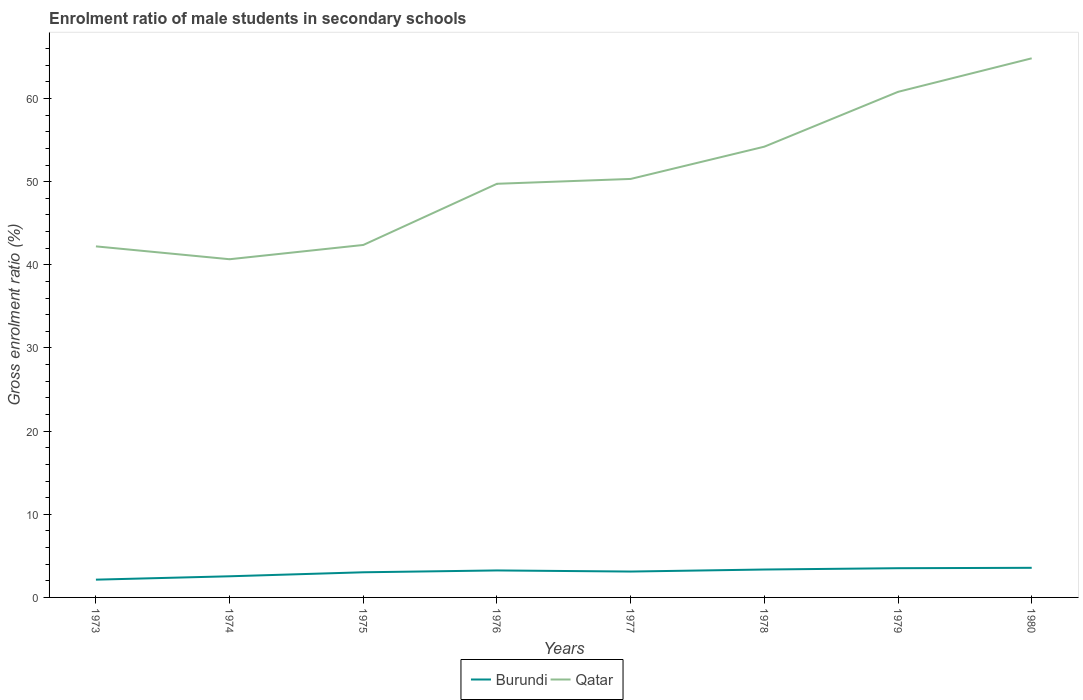How many different coloured lines are there?
Keep it short and to the point. 2. Does the line corresponding to Burundi intersect with the line corresponding to Qatar?
Offer a terse response. No. Across all years, what is the maximum enrolment ratio of male students in secondary schools in Qatar?
Offer a very short reply. 40.68. What is the total enrolment ratio of male students in secondary schools in Burundi in the graph?
Ensure brevity in your answer.  -0.57. What is the difference between the highest and the second highest enrolment ratio of male students in secondary schools in Qatar?
Give a very brief answer. 24.16. What is the difference between the highest and the lowest enrolment ratio of male students in secondary schools in Qatar?
Your answer should be very brief. 3. Is the enrolment ratio of male students in secondary schools in Qatar strictly greater than the enrolment ratio of male students in secondary schools in Burundi over the years?
Your response must be concise. No. How many years are there in the graph?
Provide a succinct answer. 8. What is the difference between two consecutive major ticks on the Y-axis?
Your answer should be very brief. 10. Does the graph contain any zero values?
Your response must be concise. No. Does the graph contain grids?
Ensure brevity in your answer.  No. How are the legend labels stacked?
Ensure brevity in your answer.  Horizontal. What is the title of the graph?
Your response must be concise. Enrolment ratio of male students in secondary schools. Does "Dominica" appear as one of the legend labels in the graph?
Your answer should be compact. No. What is the label or title of the X-axis?
Your answer should be compact. Years. What is the label or title of the Y-axis?
Offer a terse response. Gross enrolment ratio (%). What is the Gross enrolment ratio (%) of Burundi in 1973?
Provide a short and direct response. 2.14. What is the Gross enrolment ratio (%) of Qatar in 1973?
Offer a terse response. 42.22. What is the Gross enrolment ratio (%) of Burundi in 1974?
Offer a very short reply. 2.54. What is the Gross enrolment ratio (%) in Qatar in 1974?
Your answer should be very brief. 40.68. What is the Gross enrolment ratio (%) of Burundi in 1975?
Ensure brevity in your answer.  3.02. What is the Gross enrolment ratio (%) in Qatar in 1975?
Provide a short and direct response. 42.39. What is the Gross enrolment ratio (%) of Burundi in 1976?
Give a very brief answer. 3.25. What is the Gross enrolment ratio (%) of Qatar in 1976?
Ensure brevity in your answer.  49.75. What is the Gross enrolment ratio (%) in Burundi in 1977?
Your answer should be compact. 3.11. What is the Gross enrolment ratio (%) of Qatar in 1977?
Provide a succinct answer. 50.33. What is the Gross enrolment ratio (%) of Burundi in 1978?
Your answer should be very brief. 3.36. What is the Gross enrolment ratio (%) of Qatar in 1978?
Offer a very short reply. 54.21. What is the Gross enrolment ratio (%) of Burundi in 1979?
Keep it short and to the point. 3.52. What is the Gross enrolment ratio (%) in Qatar in 1979?
Your answer should be compact. 60.81. What is the Gross enrolment ratio (%) in Burundi in 1980?
Your response must be concise. 3.56. What is the Gross enrolment ratio (%) in Qatar in 1980?
Your answer should be compact. 64.84. Across all years, what is the maximum Gross enrolment ratio (%) of Burundi?
Provide a succinct answer. 3.56. Across all years, what is the maximum Gross enrolment ratio (%) of Qatar?
Ensure brevity in your answer.  64.84. Across all years, what is the minimum Gross enrolment ratio (%) of Burundi?
Ensure brevity in your answer.  2.14. Across all years, what is the minimum Gross enrolment ratio (%) in Qatar?
Your answer should be compact. 40.68. What is the total Gross enrolment ratio (%) of Burundi in the graph?
Your answer should be very brief. 24.5. What is the total Gross enrolment ratio (%) of Qatar in the graph?
Offer a very short reply. 405.24. What is the difference between the Gross enrolment ratio (%) of Burundi in 1973 and that in 1974?
Ensure brevity in your answer.  -0.41. What is the difference between the Gross enrolment ratio (%) in Qatar in 1973 and that in 1974?
Your answer should be very brief. 1.55. What is the difference between the Gross enrolment ratio (%) of Burundi in 1973 and that in 1975?
Give a very brief answer. -0.89. What is the difference between the Gross enrolment ratio (%) in Qatar in 1973 and that in 1975?
Your response must be concise. -0.17. What is the difference between the Gross enrolment ratio (%) in Burundi in 1973 and that in 1976?
Your answer should be compact. -1.11. What is the difference between the Gross enrolment ratio (%) of Qatar in 1973 and that in 1976?
Offer a very short reply. -7.53. What is the difference between the Gross enrolment ratio (%) of Burundi in 1973 and that in 1977?
Your answer should be compact. -0.97. What is the difference between the Gross enrolment ratio (%) of Qatar in 1973 and that in 1977?
Offer a very short reply. -8.11. What is the difference between the Gross enrolment ratio (%) of Burundi in 1973 and that in 1978?
Offer a very short reply. -1.22. What is the difference between the Gross enrolment ratio (%) of Qatar in 1973 and that in 1978?
Ensure brevity in your answer.  -11.99. What is the difference between the Gross enrolment ratio (%) in Burundi in 1973 and that in 1979?
Your answer should be compact. -1.38. What is the difference between the Gross enrolment ratio (%) of Qatar in 1973 and that in 1979?
Offer a very short reply. -18.58. What is the difference between the Gross enrolment ratio (%) of Burundi in 1973 and that in 1980?
Offer a terse response. -1.42. What is the difference between the Gross enrolment ratio (%) in Qatar in 1973 and that in 1980?
Keep it short and to the point. -22.62. What is the difference between the Gross enrolment ratio (%) in Burundi in 1974 and that in 1975?
Your response must be concise. -0.48. What is the difference between the Gross enrolment ratio (%) in Qatar in 1974 and that in 1975?
Give a very brief answer. -1.72. What is the difference between the Gross enrolment ratio (%) of Burundi in 1974 and that in 1976?
Provide a short and direct response. -0.7. What is the difference between the Gross enrolment ratio (%) of Qatar in 1974 and that in 1976?
Provide a succinct answer. -9.07. What is the difference between the Gross enrolment ratio (%) of Burundi in 1974 and that in 1977?
Your answer should be compact. -0.57. What is the difference between the Gross enrolment ratio (%) in Qatar in 1974 and that in 1977?
Your answer should be very brief. -9.66. What is the difference between the Gross enrolment ratio (%) of Burundi in 1974 and that in 1978?
Ensure brevity in your answer.  -0.81. What is the difference between the Gross enrolment ratio (%) of Qatar in 1974 and that in 1978?
Make the answer very short. -13.54. What is the difference between the Gross enrolment ratio (%) of Burundi in 1974 and that in 1979?
Your answer should be very brief. -0.97. What is the difference between the Gross enrolment ratio (%) of Qatar in 1974 and that in 1979?
Offer a terse response. -20.13. What is the difference between the Gross enrolment ratio (%) of Burundi in 1974 and that in 1980?
Offer a terse response. -1.02. What is the difference between the Gross enrolment ratio (%) in Qatar in 1974 and that in 1980?
Ensure brevity in your answer.  -24.16. What is the difference between the Gross enrolment ratio (%) of Burundi in 1975 and that in 1976?
Provide a succinct answer. -0.22. What is the difference between the Gross enrolment ratio (%) in Qatar in 1975 and that in 1976?
Ensure brevity in your answer.  -7.36. What is the difference between the Gross enrolment ratio (%) of Burundi in 1975 and that in 1977?
Give a very brief answer. -0.09. What is the difference between the Gross enrolment ratio (%) in Qatar in 1975 and that in 1977?
Ensure brevity in your answer.  -7.94. What is the difference between the Gross enrolment ratio (%) in Burundi in 1975 and that in 1978?
Make the answer very short. -0.33. What is the difference between the Gross enrolment ratio (%) of Qatar in 1975 and that in 1978?
Offer a very short reply. -11.82. What is the difference between the Gross enrolment ratio (%) in Burundi in 1975 and that in 1979?
Your answer should be very brief. -0.49. What is the difference between the Gross enrolment ratio (%) in Qatar in 1975 and that in 1979?
Provide a short and direct response. -18.42. What is the difference between the Gross enrolment ratio (%) of Burundi in 1975 and that in 1980?
Your response must be concise. -0.54. What is the difference between the Gross enrolment ratio (%) of Qatar in 1975 and that in 1980?
Ensure brevity in your answer.  -22.45. What is the difference between the Gross enrolment ratio (%) in Burundi in 1976 and that in 1977?
Provide a succinct answer. 0.13. What is the difference between the Gross enrolment ratio (%) in Qatar in 1976 and that in 1977?
Give a very brief answer. -0.58. What is the difference between the Gross enrolment ratio (%) of Burundi in 1976 and that in 1978?
Your response must be concise. -0.11. What is the difference between the Gross enrolment ratio (%) in Qatar in 1976 and that in 1978?
Provide a short and direct response. -4.46. What is the difference between the Gross enrolment ratio (%) in Burundi in 1976 and that in 1979?
Provide a succinct answer. -0.27. What is the difference between the Gross enrolment ratio (%) of Qatar in 1976 and that in 1979?
Your answer should be very brief. -11.06. What is the difference between the Gross enrolment ratio (%) in Burundi in 1976 and that in 1980?
Offer a very short reply. -0.32. What is the difference between the Gross enrolment ratio (%) of Qatar in 1976 and that in 1980?
Keep it short and to the point. -15.09. What is the difference between the Gross enrolment ratio (%) of Burundi in 1977 and that in 1978?
Offer a terse response. -0.25. What is the difference between the Gross enrolment ratio (%) in Qatar in 1977 and that in 1978?
Your answer should be compact. -3.88. What is the difference between the Gross enrolment ratio (%) in Burundi in 1977 and that in 1979?
Offer a terse response. -0.4. What is the difference between the Gross enrolment ratio (%) in Qatar in 1977 and that in 1979?
Keep it short and to the point. -10.47. What is the difference between the Gross enrolment ratio (%) of Burundi in 1977 and that in 1980?
Offer a very short reply. -0.45. What is the difference between the Gross enrolment ratio (%) in Qatar in 1977 and that in 1980?
Provide a short and direct response. -14.51. What is the difference between the Gross enrolment ratio (%) of Burundi in 1978 and that in 1979?
Your answer should be very brief. -0.16. What is the difference between the Gross enrolment ratio (%) of Qatar in 1978 and that in 1979?
Your response must be concise. -6.59. What is the difference between the Gross enrolment ratio (%) of Burundi in 1978 and that in 1980?
Provide a short and direct response. -0.2. What is the difference between the Gross enrolment ratio (%) in Qatar in 1978 and that in 1980?
Keep it short and to the point. -10.63. What is the difference between the Gross enrolment ratio (%) of Burundi in 1979 and that in 1980?
Provide a succinct answer. -0.05. What is the difference between the Gross enrolment ratio (%) of Qatar in 1979 and that in 1980?
Your response must be concise. -4.03. What is the difference between the Gross enrolment ratio (%) in Burundi in 1973 and the Gross enrolment ratio (%) in Qatar in 1974?
Provide a succinct answer. -38.54. What is the difference between the Gross enrolment ratio (%) of Burundi in 1973 and the Gross enrolment ratio (%) of Qatar in 1975?
Offer a terse response. -40.25. What is the difference between the Gross enrolment ratio (%) in Burundi in 1973 and the Gross enrolment ratio (%) in Qatar in 1976?
Provide a succinct answer. -47.61. What is the difference between the Gross enrolment ratio (%) of Burundi in 1973 and the Gross enrolment ratio (%) of Qatar in 1977?
Your response must be concise. -48.2. What is the difference between the Gross enrolment ratio (%) of Burundi in 1973 and the Gross enrolment ratio (%) of Qatar in 1978?
Provide a succinct answer. -52.08. What is the difference between the Gross enrolment ratio (%) of Burundi in 1973 and the Gross enrolment ratio (%) of Qatar in 1979?
Offer a very short reply. -58.67. What is the difference between the Gross enrolment ratio (%) in Burundi in 1973 and the Gross enrolment ratio (%) in Qatar in 1980?
Your response must be concise. -62.7. What is the difference between the Gross enrolment ratio (%) of Burundi in 1974 and the Gross enrolment ratio (%) of Qatar in 1975?
Provide a short and direct response. -39.85. What is the difference between the Gross enrolment ratio (%) in Burundi in 1974 and the Gross enrolment ratio (%) in Qatar in 1976?
Your answer should be compact. -47.21. What is the difference between the Gross enrolment ratio (%) of Burundi in 1974 and the Gross enrolment ratio (%) of Qatar in 1977?
Keep it short and to the point. -47.79. What is the difference between the Gross enrolment ratio (%) in Burundi in 1974 and the Gross enrolment ratio (%) in Qatar in 1978?
Offer a very short reply. -51.67. What is the difference between the Gross enrolment ratio (%) in Burundi in 1974 and the Gross enrolment ratio (%) in Qatar in 1979?
Make the answer very short. -58.26. What is the difference between the Gross enrolment ratio (%) of Burundi in 1974 and the Gross enrolment ratio (%) of Qatar in 1980?
Keep it short and to the point. -62.3. What is the difference between the Gross enrolment ratio (%) of Burundi in 1975 and the Gross enrolment ratio (%) of Qatar in 1976?
Offer a terse response. -46.73. What is the difference between the Gross enrolment ratio (%) in Burundi in 1975 and the Gross enrolment ratio (%) in Qatar in 1977?
Provide a succinct answer. -47.31. What is the difference between the Gross enrolment ratio (%) in Burundi in 1975 and the Gross enrolment ratio (%) in Qatar in 1978?
Provide a succinct answer. -51.19. What is the difference between the Gross enrolment ratio (%) in Burundi in 1975 and the Gross enrolment ratio (%) in Qatar in 1979?
Make the answer very short. -57.78. What is the difference between the Gross enrolment ratio (%) in Burundi in 1975 and the Gross enrolment ratio (%) in Qatar in 1980?
Provide a short and direct response. -61.82. What is the difference between the Gross enrolment ratio (%) of Burundi in 1976 and the Gross enrolment ratio (%) of Qatar in 1977?
Your response must be concise. -47.09. What is the difference between the Gross enrolment ratio (%) in Burundi in 1976 and the Gross enrolment ratio (%) in Qatar in 1978?
Your response must be concise. -50.97. What is the difference between the Gross enrolment ratio (%) in Burundi in 1976 and the Gross enrolment ratio (%) in Qatar in 1979?
Your answer should be compact. -57.56. What is the difference between the Gross enrolment ratio (%) in Burundi in 1976 and the Gross enrolment ratio (%) in Qatar in 1980?
Keep it short and to the point. -61.6. What is the difference between the Gross enrolment ratio (%) in Burundi in 1977 and the Gross enrolment ratio (%) in Qatar in 1978?
Offer a very short reply. -51.1. What is the difference between the Gross enrolment ratio (%) in Burundi in 1977 and the Gross enrolment ratio (%) in Qatar in 1979?
Give a very brief answer. -57.7. What is the difference between the Gross enrolment ratio (%) in Burundi in 1977 and the Gross enrolment ratio (%) in Qatar in 1980?
Offer a very short reply. -61.73. What is the difference between the Gross enrolment ratio (%) of Burundi in 1978 and the Gross enrolment ratio (%) of Qatar in 1979?
Ensure brevity in your answer.  -57.45. What is the difference between the Gross enrolment ratio (%) of Burundi in 1978 and the Gross enrolment ratio (%) of Qatar in 1980?
Your response must be concise. -61.48. What is the difference between the Gross enrolment ratio (%) in Burundi in 1979 and the Gross enrolment ratio (%) in Qatar in 1980?
Give a very brief answer. -61.33. What is the average Gross enrolment ratio (%) in Burundi per year?
Provide a succinct answer. 3.06. What is the average Gross enrolment ratio (%) of Qatar per year?
Your answer should be very brief. 50.65. In the year 1973, what is the difference between the Gross enrolment ratio (%) of Burundi and Gross enrolment ratio (%) of Qatar?
Your response must be concise. -40.09. In the year 1974, what is the difference between the Gross enrolment ratio (%) in Burundi and Gross enrolment ratio (%) in Qatar?
Your response must be concise. -38.13. In the year 1975, what is the difference between the Gross enrolment ratio (%) of Burundi and Gross enrolment ratio (%) of Qatar?
Offer a terse response. -39.37. In the year 1976, what is the difference between the Gross enrolment ratio (%) in Burundi and Gross enrolment ratio (%) in Qatar?
Provide a succinct answer. -46.5. In the year 1977, what is the difference between the Gross enrolment ratio (%) in Burundi and Gross enrolment ratio (%) in Qatar?
Offer a very short reply. -47.22. In the year 1978, what is the difference between the Gross enrolment ratio (%) in Burundi and Gross enrolment ratio (%) in Qatar?
Your answer should be very brief. -50.86. In the year 1979, what is the difference between the Gross enrolment ratio (%) in Burundi and Gross enrolment ratio (%) in Qatar?
Provide a succinct answer. -57.29. In the year 1980, what is the difference between the Gross enrolment ratio (%) of Burundi and Gross enrolment ratio (%) of Qatar?
Your answer should be very brief. -61.28. What is the ratio of the Gross enrolment ratio (%) of Burundi in 1973 to that in 1974?
Ensure brevity in your answer.  0.84. What is the ratio of the Gross enrolment ratio (%) of Qatar in 1973 to that in 1974?
Your answer should be very brief. 1.04. What is the ratio of the Gross enrolment ratio (%) in Burundi in 1973 to that in 1975?
Provide a succinct answer. 0.71. What is the ratio of the Gross enrolment ratio (%) in Burundi in 1973 to that in 1976?
Offer a terse response. 0.66. What is the ratio of the Gross enrolment ratio (%) of Qatar in 1973 to that in 1976?
Keep it short and to the point. 0.85. What is the ratio of the Gross enrolment ratio (%) in Burundi in 1973 to that in 1977?
Ensure brevity in your answer.  0.69. What is the ratio of the Gross enrolment ratio (%) of Qatar in 1973 to that in 1977?
Provide a short and direct response. 0.84. What is the ratio of the Gross enrolment ratio (%) in Burundi in 1973 to that in 1978?
Offer a very short reply. 0.64. What is the ratio of the Gross enrolment ratio (%) of Qatar in 1973 to that in 1978?
Make the answer very short. 0.78. What is the ratio of the Gross enrolment ratio (%) of Burundi in 1973 to that in 1979?
Your response must be concise. 0.61. What is the ratio of the Gross enrolment ratio (%) of Qatar in 1973 to that in 1979?
Offer a very short reply. 0.69. What is the ratio of the Gross enrolment ratio (%) in Burundi in 1973 to that in 1980?
Offer a terse response. 0.6. What is the ratio of the Gross enrolment ratio (%) of Qatar in 1973 to that in 1980?
Make the answer very short. 0.65. What is the ratio of the Gross enrolment ratio (%) of Burundi in 1974 to that in 1975?
Provide a succinct answer. 0.84. What is the ratio of the Gross enrolment ratio (%) of Qatar in 1974 to that in 1975?
Ensure brevity in your answer.  0.96. What is the ratio of the Gross enrolment ratio (%) in Burundi in 1974 to that in 1976?
Your answer should be compact. 0.78. What is the ratio of the Gross enrolment ratio (%) of Qatar in 1974 to that in 1976?
Keep it short and to the point. 0.82. What is the ratio of the Gross enrolment ratio (%) of Burundi in 1974 to that in 1977?
Keep it short and to the point. 0.82. What is the ratio of the Gross enrolment ratio (%) in Qatar in 1974 to that in 1977?
Provide a succinct answer. 0.81. What is the ratio of the Gross enrolment ratio (%) of Burundi in 1974 to that in 1978?
Make the answer very short. 0.76. What is the ratio of the Gross enrolment ratio (%) in Qatar in 1974 to that in 1978?
Give a very brief answer. 0.75. What is the ratio of the Gross enrolment ratio (%) in Burundi in 1974 to that in 1979?
Offer a terse response. 0.72. What is the ratio of the Gross enrolment ratio (%) of Qatar in 1974 to that in 1979?
Provide a short and direct response. 0.67. What is the ratio of the Gross enrolment ratio (%) in Burundi in 1974 to that in 1980?
Your answer should be compact. 0.71. What is the ratio of the Gross enrolment ratio (%) in Qatar in 1974 to that in 1980?
Keep it short and to the point. 0.63. What is the ratio of the Gross enrolment ratio (%) in Burundi in 1975 to that in 1976?
Give a very brief answer. 0.93. What is the ratio of the Gross enrolment ratio (%) in Qatar in 1975 to that in 1976?
Your response must be concise. 0.85. What is the ratio of the Gross enrolment ratio (%) in Burundi in 1975 to that in 1977?
Offer a very short reply. 0.97. What is the ratio of the Gross enrolment ratio (%) in Qatar in 1975 to that in 1977?
Ensure brevity in your answer.  0.84. What is the ratio of the Gross enrolment ratio (%) in Burundi in 1975 to that in 1978?
Keep it short and to the point. 0.9. What is the ratio of the Gross enrolment ratio (%) in Qatar in 1975 to that in 1978?
Your answer should be very brief. 0.78. What is the ratio of the Gross enrolment ratio (%) in Burundi in 1975 to that in 1979?
Make the answer very short. 0.86. What is the ratio of the Gross enrolment ratio (%) in Qatar in 1975 to that in 1979?
Your answer should be compact. 0.7. What is the ratio of the Gross enrolment ratio (%) in Burundi in 1975 to that in 1980?
Provide a succinct answer. 0.85. What is the ratio of the Gross enrolment ratio (%) of Qatar in 1975 to that in 1980?
Give a very brief answer. 0.65. What is the ratio of the Gross enrolment ratio (%) in Burundi in 1976 to that in 1977?
Your response must be concise. 1.04. What is the ratio of the Gross enrolment ratio (%) in Qatar in 1976 to that in 1977?
Make the answer very short. 0.99. What is the ratio of the Gross enrolment ratio (%) of Burundi in 1976 to that in 1978?
Keep it short and to the point. 0.97. What is the ratio of the Gross enrolment ratio (%) of Qatar in 1976 to that in 1978?
Provide a short and direct response. 0.92. What is the ratio of the Gross enrolment ratio (%) in Burundi in 1976 to that in 1979?
Give a very brief answer. 0.92. What is the ratio of the Gross enrolment ratio (%) in Qatar in 1976 to that in 1979?
Provide a short and direct response. 0.82. What is the ratio of the Gross enrolment ratio (%) in Burundi in 1976 to that in 1980?
Keep it short and to the point. 0.91. What is the ratio of the Gross enrolment ratio (%) of Qatar in 1976 to that in 1980?
Your response must be concise. 0.77. What is the ratio of the Gross enrolment ratio (%) in Burundi in 1977 to that in 1978?
Make the answer very short. 0.93. What is the ratio of the Gross enrolment ratio (%) of Qatar in 1977 to that in 1978?
Offer a very short reply. 0.93. What is the ratio of the Gross enrolment ratio (%) in Burundi in 1977 to that in 1979?
Your response must be concise. 0.89. What is the ratio of the Gross enrolment ratio (%) of Qatar in 1977 to that in 1979?
Ensure brevity in your answer.  0.83. What is the ratio of the Gross enrolment ratio (%) in Burundi in 1977 to that in 1980?
Your answer should be very brief. 0.87. What is the ratio of the Gross enrolment ratio (%) in Qatar in 1977 to that in 1980?
Your answer should be compact. 0.78. What is the ratio of the Gross enrolment ratio (%) of Burundi in 1978 to that in 1979?
Make the answer very short. 0.96. What is the ratio of the Gross enrolment ratio (%) in Qatar in 1978 to that in 1979?
Give a very brief answer. 0.89. What is the ratio of the Gross enrolment ratio (%) in Burundi in 1978 to that in 1980?
Make the answer very short. 0.94. What is the ratio of the Gross enrolment ratio (%) of Qatar in 1978 to that in 1980?
Your answer should be compact. 0.84. What is the ratio of the Gross enrolment ratio (%) in Qatar in 1979 to that in 1980?
Offer a terse response. 0.94. What is the difference between the highest and the second highest Gross enrolment ratio (%) of Burundi?
Your answer should be very brief. 0.05. What is the difference between the highest and the second highest Gross enrolment ratio (%) of Qatar?
Keep it short and to the point. 4.03. What is the difference between the highest and the lowest Gross enrolment ratio (%) of Burundi?
Offer a terse response. 1.42. What is the difference between the highest and the lowest Gross enrolment ratio (%) of Qatar?
Provide a succinct answer. 24.16. 